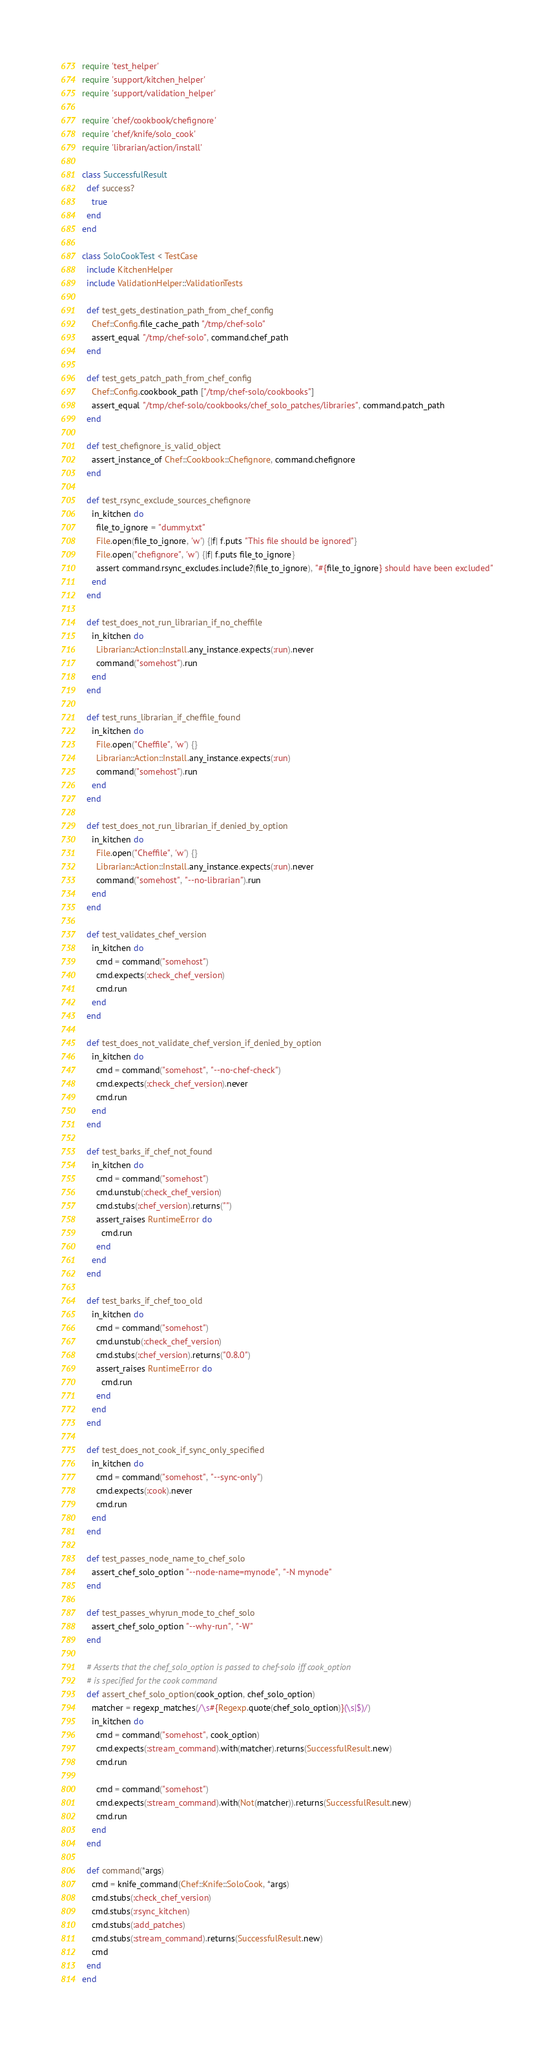Convert code to text. <code><loc_0><loc_0><loc_500><loc_500><_Ruby_>require 'test_helper'
require 'support/kitchen_helper'
require 'support/validation_helper'

require 'chef/cookbook/chefignore'
require 'chef/knife/solo_cook'
require 'librarian/action/install'

class SuccessfulResult
  def success?
    true
  end
end

class SoloCookTest < TestCase
  include KitchenHelper
  include ValidationHelper::ValidationTests

  def test_gets_destination_path_from_chef_config
    Chef::Config.file_cache_path "/tmp/chef-solo"
    assert_equal "/tmp/chef-solo", command.chef_path
  end

  def test_gets_patch_path_from_chef_config
    Chef::Config.cookbook_path ["/tmp/chef-solo/cookbooks"]
    assert_equal "/tmp/chef-solo/cookbooks/chef_solo_patches/libraries", command.patch_path
  end

  def test_chefignore_is_valid_object
    assert_instance_of Chef::Cookbook::Chefignore, command.chefignore
  end

  def test_rsync_exclude_sources_chefignore
    in_kitchen do
      file_to_ignore = "dummy.txt"
      File.open(file_to_ignore, 'w') {|f| f.puts "This file should be ignored"}
      File.open("chefignore", 'w') {|f| f.puts file_to_ignore}
      assert command.rsync_excludes.include?(file_to_ignore), "#{file_to_ignore} should have been excluded"
    end
  end

  def test_does_not_run_librarian_if_no_cheffile
    in_kitchen do
      Librarian::Action::Install.any_instance.expects(:run).never
      command("somehost").run
    end
  end

  def test_runs_librarian_if_cheffile_found
    in_kitchen do
      File.open("Cheffile", 'w') {}
      Librarian::Action::Install.any_instance.expects(:run)
      command("somehost").run
    end
  end

  def test_does_not_run_librarian_if_denied_by_option
    in_kitchen do
      File.open("Cheffile", 'w') {}
      Librarian::Action::Install.any_instance.expects(:run).never
      command("somehost", "--no-librarian").run
    end
  end

  def test_validates_chef_version
    in_kitchen do
      cmd = command("somehost")
      cmd.expects(:check_chef_version)
      cmd.run
    end
  end

  def test_does_not_validate_chef_version_if_denied_by_option
    in_kitchen do
      cmd = command("somehost", "--no-chef-check")
      cmd.expects(:check_chef_version).never
      cmd.run
    end
  end

  def test_barks_if_chef_not_found
    in_kitchen do
      cmd = command("somehost")
      cmd.unstub(:check_chef_version)
      cmd.stubs(:chef_version).returns("")
      assert_raises RuntimeError do
        cmd.run
      end
    end
  end

  def test_barks_if_chef_too_old
    in_kitchen do
      cmd = command("somehost")
      cmd.unstub(:check_chef_version)
      cmd.stubs(:chef_version).returns("0.8.0")
      assert_raises RuntimeError do
        cmd.run
      end
    end
  end

  def test_does_not_cook_if_sync_only_specified
    in_kitchen do
      cmd = command("somehost", "--sync-only")
      cmd.expects(:cook).never
      cmd.run
    end
  end

  def test_passes_node_name_to_chef_solo
    assert_chef_solo_option "--node-name=mynode", "-N mynode"
  end

  def test_passes_whyrun_mode_to_chef_solo
    assert_chef_solo_option "--why-run", "-W"
  end

  # Asserts that the chef_solo_option is passed to chef-solo iff cook_option
  # is specified for the cook command
  def assert_chef_solo_option(cook_option, chef_solo_option)
    matcher = regexp_matches(/\s#{Regexp.quote(chef_solo_option)}(\s|$)/)
    in_kitchen do
      cmd = command("somehost", cook_option)
      cmd.expects(:stream_command).with(matcher).returns(SuccessfulResult.new)
      cmd.run

      cmd = command("somehost")
      cmd.expects(:stream_command).with(Not(matcher)).returns(SuccessfulResult.new)
      cmd.run
    end
  end

  def command(*args)
    cmd = knife_command(Chef::Knife::SoloCook, *args)
    cmd.stubs(:check_chef_version)
    cmd.stubs(:rsync_kitchen)
    cmd.stubs(:add_patches)
    cmd.stubs(:stream_command).returns(SuccessfulResult.new)
    cmd
  end
end
</code> 